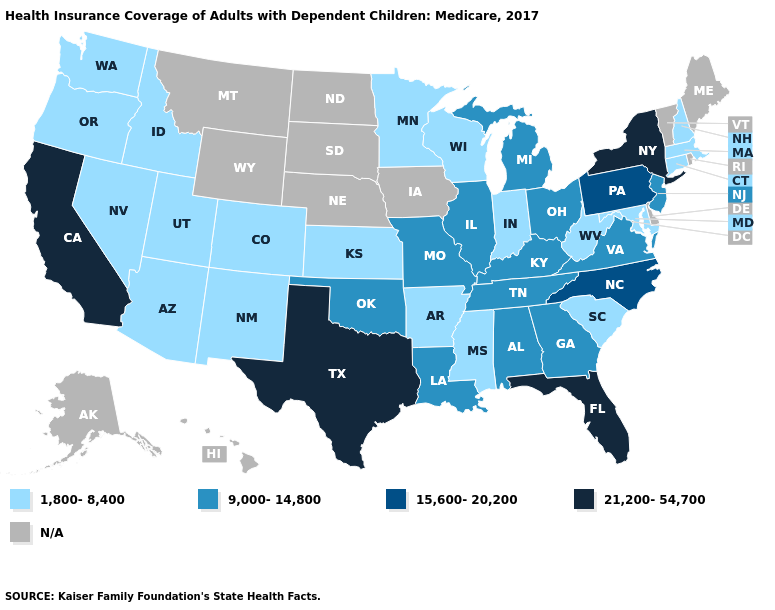Among the states that border Tennessee , does North Carolina have the highest value?
Concise answer only. Yes. Does New Jersey have the highest value in the USA?
Write a very short answer. No. Name the states that have a value in the range N/A?
Keep it brief. Alaska, Delaware, Hawaii, Iowa, Maine, Montana, Nebraska, North Dakota, Rhode Island, South Dakota, Vermont, Wyoming. What is the value of New York?
Keep it brief. 21,200-54,700. What is the lowest value in the Northeast?
Answer briefly. 1,800-8,400. Which states have the highest value in the USA?
Keep it brief. California, Florida, New York, Texas. Name the states that have a value in the range 9,000-14,800?
Keep it brief. Alabama, Georgia, Illinois, Kentucky, Louisiana, Michigan, Missouri, New Jersey, Ohio, Oklahoma, Tennessee, Virginia. What is the value of Florida?
Be succinct. 21,200-54,700. Name the states that have a value in the range 21,200-54,700?
Short answer required. California, Florida, New York, Texas. Does California have the lowest value in the USA?
Answer briefly. No. Does Massachusetts have the lowest value in the USA?
Answer briefly. Yes. What is the highest value in the Northeast ?
Answer briefly. 21,200-54,700. What is the highest value in the USA?
Concise answer only. 21,200-54,700. What is the lowest value in states that border New Hampshire?
Quick response, please. 1,800-8,400. Name the states that have a value in the range 15,600-20,200?
Answer briefly. North Carolina, Pennsylvania. 